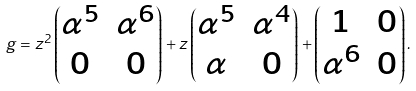<formula> <loc_0><loc_0><loc_500><loc_500>g = z ^ { 2 } \left ( \begin{matrix} \alpha ^ { 5 } & \alpha ^ { 6 } \\ 0 & 0 \end{matrix} \right ) + z \left ( \begin{matrix} \alpha ^ { 5 } & \alpha ^ { 4 } \\ \alpha & 0 \end{matrix} \right ) + \left ( \begin{matrix} 1 & 0 \\ \alpha ^ { 6 } & 0 \end{matrix} \right ) .</formula> 